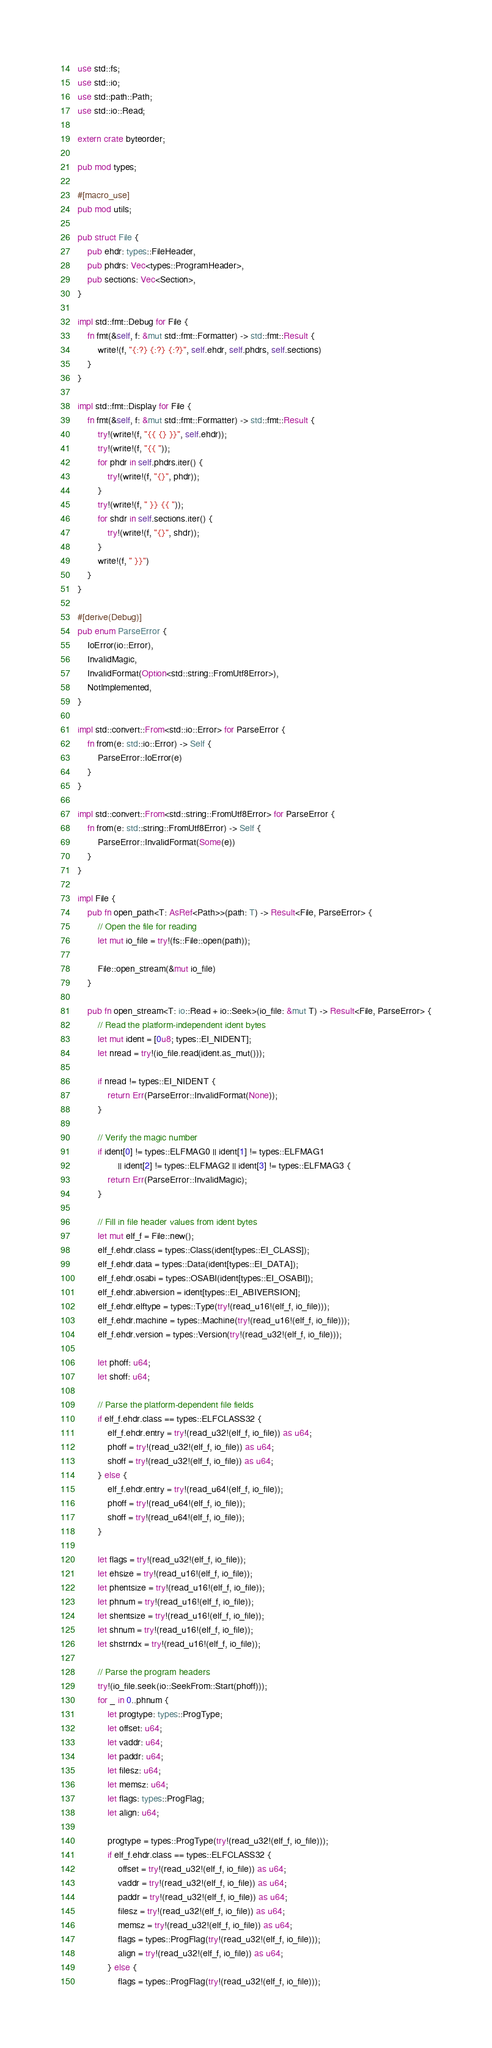<code> <loc_0><loc_0><loc_500><loc_500><_Rust_>use std::fs;
use std::io;
use std::path::Path;
use std::io::Read;

extern crate byteorder;

pub mod types;

#[macro_use]
pub mod utils;

pub struct File {
    pub ehdr: types::FileHeader,
    pub phdrs: Vec<types::ProgramHeader>,
    pub sections: Vec<Section>,
}

impl std::fmt::Debug for File {
    fn fmt(&self, f: &mut std::fmt::Formatter) -> std::fmt::Result {
        write!(f, "{:?} {:?} {:?}", self.ehdr, self.phdrs, self.sections)
    }
}

impl std::fmt::Display for File {
    fn fmt(&self, f: &mut std::fmt::Formatter) -> std::fmt::Result {
        try!(write!(f, "{{ {} }}", self.ehdr));
        try!(write!(f, "{{ "));
        for phdr in self.phdrs.iter() {
            try!(write!(f, "{}", phdr));
        }
        try!(write!(f, " }} {{ "));
        for shdr in self.sections.iter() {
            try!(write!(f, "{}", shdr));
        }
        write!(f, " }}")
    }
}

#[derive(Debug)]
pub enum ParseError {
    IoError(io::Error),
    InvalidMagic,
    InvalidFormat(Option<std::string::FromUtf8Error>),
    NotImplemented,
}

impl std::convert::From<std::io::Error> for ParseError {
    fn from(e: std::io::Error) -> Self {
        ParseError::IoError(e)
    }
}

impl std::convert::From<std::string::FromUtf8Error> for ParseError {
    fn from(e: std::string::FromUtf8Error) -> Self {
        ParseError::InvalidFormat(Some(e))
    }
}

impl File {
    pub fn open_path<T: AsRef<Path>>(path: T) -> Result<File, ParseError> {
        // Open the file for reading
        let mut io_file = try!(fs::File::open(path));

        File::open_stream(&mut io_file)
    }

    pub fn open_stream<T: io::Read + io::Seek>(io_file: &mut T) -> Result<File, ParseError> {
        // Read the platform-independent ident bytes
        let mut ident = [0u8; types::EI_NIDENT];
        let nread = try!(io_file.read(ident.as_mut()));

        if nread != types::EI_NIDENT {
            return Err(ParseError::InvalidFormat(None));
        }

        // Verify the magic number
        if ident[0] != types::ELFMAG0 || ident[1] != types::ELFMAG1
                || ident[2] != types::ELFMAG2 || ident[3] != types::ELFMAG3 {
            return Err(ParseError::InvalidMagic);
        }

        // Fill in file header values from ident bytes
        let mut elf_f = File::new();
        elf_f.ehdr.class = types::Class(ident[types::EI_CLASS]);
        elf_f.ehdr.data = types::Data(ident[types::EI_DATA]);
        elf_f.ehdr.osabi = types::OSABI(ident[types::EI_OSABI]);
        elf_f.ehdr.abiversion = ident[types::EI_ABIVERSION];
        elf_f.ehdr.elftype = types::Type(try!(read_u16!(elf_f, io_file)));
        elf_f.ehdr.machine = types::Machine(try!(read_u16!(elf_f, io_file)));
        elf_f.ehdr.version = types::Version(try!(read_u32!(elf_f, io_file)));

        let phoff: u64;
        let shoff: u64;

        // Parse the platform-dependent file fields
        if elf_f.ehdr.class == types::ELFCLASS32 {
            elf_f.ehdr.entry = try!(read_u32!(elf_f, io_file)) as u64;
            phoff = try!(read_u32!(elf_f, io_file)) as u64;
            shoff = try!(read_u32!(elf_f, io_file)) as u64;
        } else {
            elf_f.ehdr.entry = try!(read_u64!(elf_f, io_file));
            phoff = try!(read_u64!(elf_f, io_file));
            shoff = try!(read_u64!(elf_f, io_file));
        }

        let flags = try!(read_u32!(elf_f, io_file));
        let ehsize = try!(read_u16!(elf_f, io_file));
        let phentsize = try!(read_u16!(elf_f, io_file));
        let phnum = try!(read_u16!(elf_f, io_file));
        let shentsize = try!(read_u16!(elf_f, io_file));
        let shnum = try!(read_u16!(elf_f, io_file));
        let shstrndx = try!(read_u16!(elf_f, io_file));

        // Parse the program headers
        try!(io_file.seek(io::SeekFrom::Start(phoff)));
        for _ in 0..phnum {
            let progtype: types::ProgType;
            let offset: u64;
            let vaddr: u64;
            let paddr: u64;
            let filesz: u64;
            let memsz: u64;
            let flags: types::ProgFlag;
            let align: u64;

            progtype = types::ProgType(try!(read_u32!(elf_f, io_file)));
            if elf_f.ehdr.class == types::ELFCLASS32 {
                offset = try!(read_u32!(elf_f, io_file)) as u64;
                vaddr = try!(read_u32!(elf_f, io_file)) as u64;
                paddr = try!(read_u32!(elf_f, io_file)) as u64;
                filesz = try!(read_u32!(elf_f, io_file)) as u64;
                memsz = try!(read_u32!(elf_f, io_file)) as u64;
                flags = types::ProgFlag(try!(read_u32!(elf_f, io_file)));
                align = try!(read_u32!(elf_f, io_file)) as u64;
            } else {
                flags = types::ProgFlag(try!(read_u32!(elf_f, io_file)));</code> 